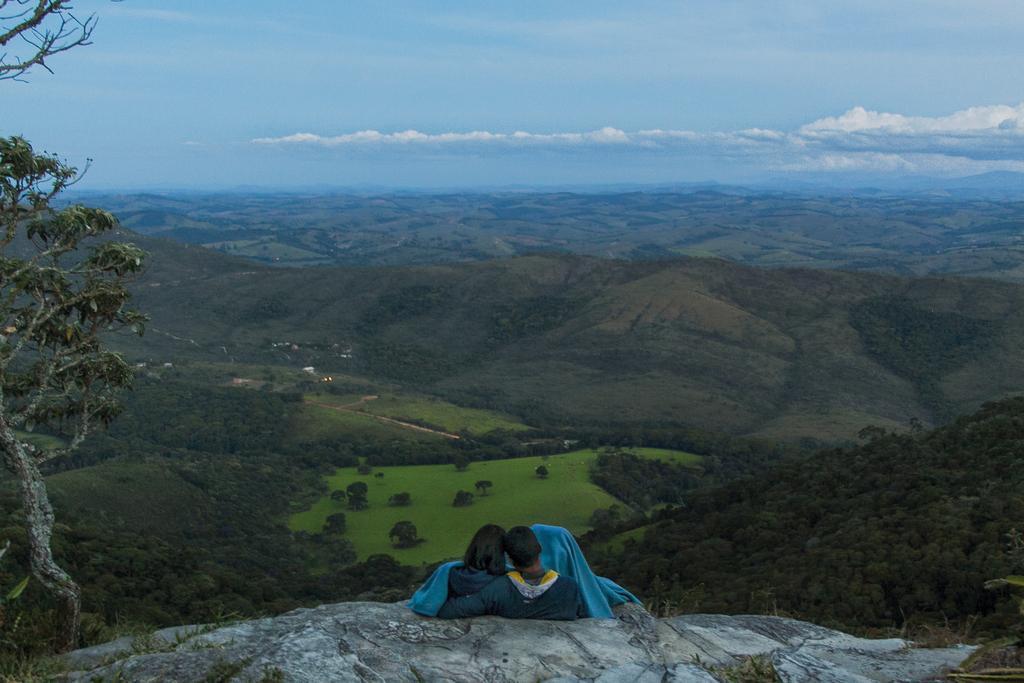Please provide a concise description of this image. In this picture, there is a rock at the bottom. On the rock, there is a woman and a man facing backwards. Towards the left, there is a tree. In the background, there are trees, grass, hills and a sky with clouds. 